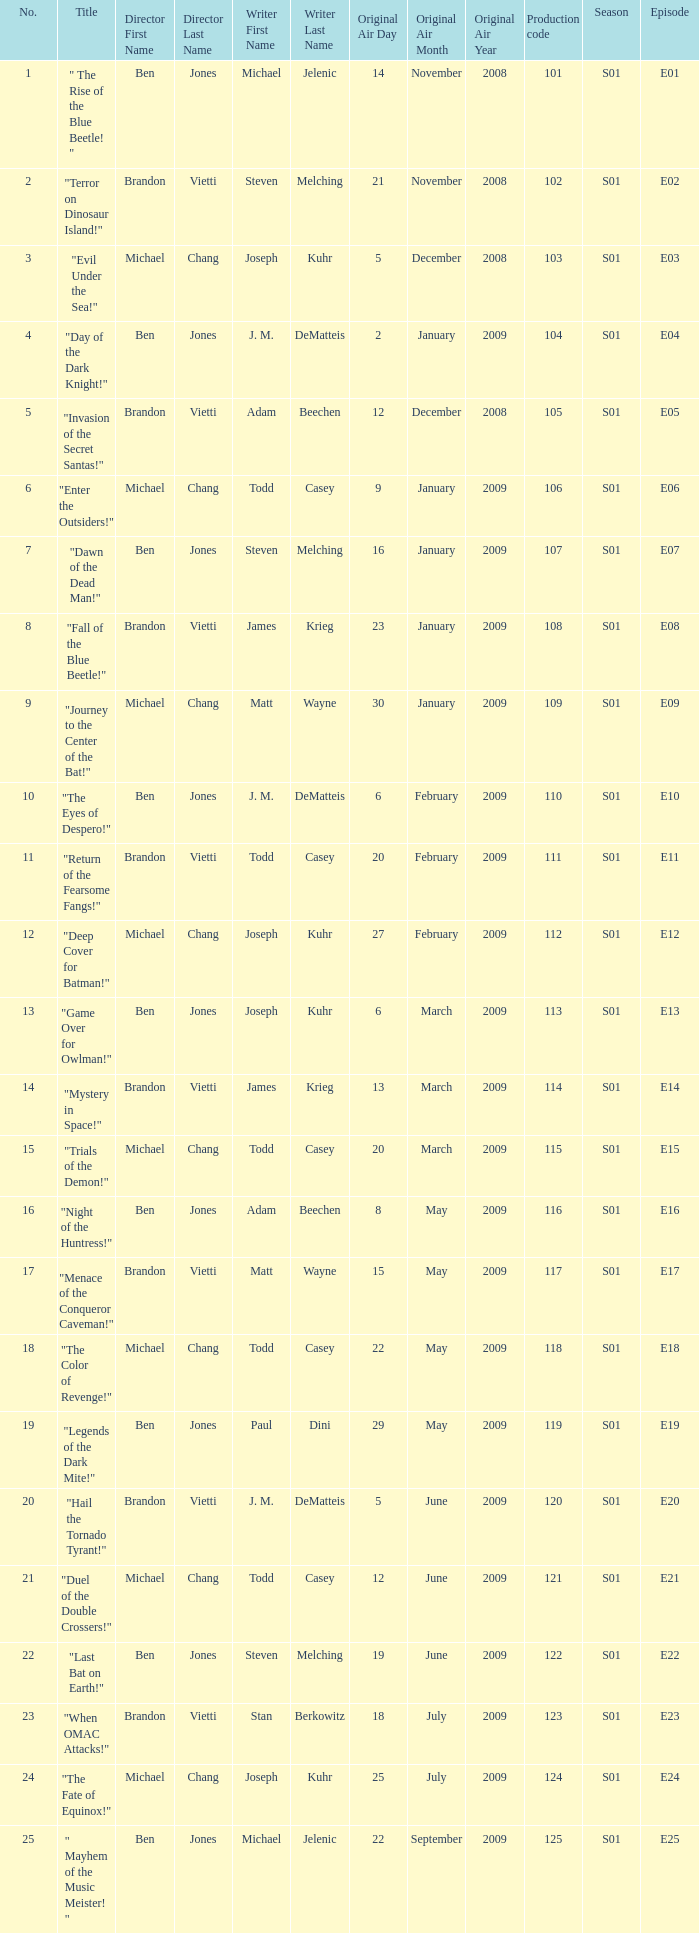Would you be able to parse every entry in this table? {'header': ['No.', 'Title', 'Director First Name', 'Director Last Name', 'Writer First Name', 'Writer Last Name', 'Original Air Day', 'Original Air Month', 'Original Air Year', 'Production code', 'Season', 'Episode'], 'rows': [['1', '" The Rise of the Blue Beetle! "', 'Ben', 'Jones', 'Michael', 'Jelenic', '14', 'November', '2008', '101', 'S01', 'E01'], ['2', '"Terror on Dinosaur Island!"', 'Brandon', 'Vietti', 'Steven', 'Melching', '21', 'November', '2008', '102', 'S01', 'E02'], ['3', '"Evil Under the Sea!"', 'Michael', 'Chang', 'Joseph', 'Kuhr', '5', 'December', '2008', '103', 'S01', 'E03'], ['4', '"Day of the Dark Knight!"', 'Ben', 'Jones', 'J. M.', 'DeMatteis', '2', 'January', '2009', '104', 'S01', 'E04'], ['5', '"Invasion of the Secret Santas!"', 'Brandon', 'Vietti', 'Adam', 'Beechen', '12', 'December', '2008', '105', 'S01', 'E05'], ['6', '"Enter the Outsiders!"', 'Michael', 'Chang', 'Todd', 'Casey', '9', 'January', '2009', '106', 'S01', 'E06'], ['7', '"Dawn of the Dead Man!"', 'Ben', 'Jones', 'Steven', 'Melching', '16', 'January', '2009', '107', 'S01', 'E07'], ['8', '"Fall of the Blue Beetle!"', 'Brandon', 'Vietti', 'James', 'Krieg', '23', 'January', '2009', '108', 'S01', 'E08'], ['9', '"Journey to the Center of the Bat!"', 'Michael', 'Chang', 'Matt', 'Wayne', '30', 'January', '2009', '109', 'S01', 'E09'], ['10', '"The Eyes of Despero!"', 'Ben', 'Jones', 'J. M.', 'DeMatteis', '6', 'February', '2009', '110', 'S01', 'E10'], ['11', '"Return of the Fearsome Fangs!"', 'Brandon', 'Vietti', 'Todd', 'Casey', '20', 'February', '2009', '111', 'S01', 'E11'], ['12', '"Deep Cover for Batman!"', 'Michael', 'Chang', 'Joseph', 'Kuhr', '27', 'February', '2009', '112', 'S01', 'E12'], ['13', '"Game Over for Owlman!"', 'Ben', 'Jones', 'Joseph', 'Kuhr', '6', 'March', '2009', '113', 'S01', 'E13'], ['14', '"Mystery in Space!"', 'Brandon', 'Vietti', 'James', 'Krieg', '13', 'March', '2009', '114', 'S01', 'E14'], ['15', '"Trials of the Demon!"', 'Michael', 'Chang', 'Todd', 'Casey', '20', 'March', '2009', '115', 'S01', 'E15'], ['16', '"Night of the Huntress!"', 'Ben', 'Jones', 'Adam', 'Beechen', '8', 'May', '2009', '116', 'S01', 'E16'], ['17', '"Menace of the Conqueror Caveman!"', 'Brandon', 'Vietti', 'Matt', 'Wayne', '15', 'May', '2009', '117', 'S01', 'E17'], ['18', '"The Color of Revenge!"', 'Michael', 'Chang', 'Todd', 'Casey', '22', 'May', '2009', '118', 'S01', 'E18'], ['19', '"Legends of the Dark Mite!"', 'Ben', 'Jones', 'Paul', 'Dini', '29', 'May', '2009', '119', 'S01', 'E19'], ['20', '"Hail the Tornado Tyrant!"', 'Brandon', 'Vietti', 'J. M.', 'DeMatteis', '5', 'June', '2009', '120', 'S01', 'E20'], ['21', '"Duel of the Double Crossers!"', 'Michael', 'Chang', 'Todd', 'Casey', '12', 'June', '2009', '121', 'S01', 'E21'], ['22', '"Last Bat on Earth!"', 'Ben', 'Jones', 'Steven', 'Melching', '19', 'June', '2009', '122', 'S01', 'E22'], ['23', '"When OMAC Attacks!"', 'Brandon', 'Vietti', 'Stan', 'Berkowitz', '18', 'July', '2009', '123', 'S01', 'E23'], ['24', '"The Fate of Equinox!"', 'Michael', 'Chang', 'Joseph', 'Kuhr', '25', 'July', '2009', '124', 'S01', 'E24'], ['25', '" Mayhem of the Music Meister! "', 'Ben', 'Jones', 'Michael', 'Jelenic', '22', 'September', '2009', '125', 'S01', 'E25']]} What is the television order of the episode directed by ben jones, written by j. m. dematteis and originally aired on february6,2009 S01E10. 